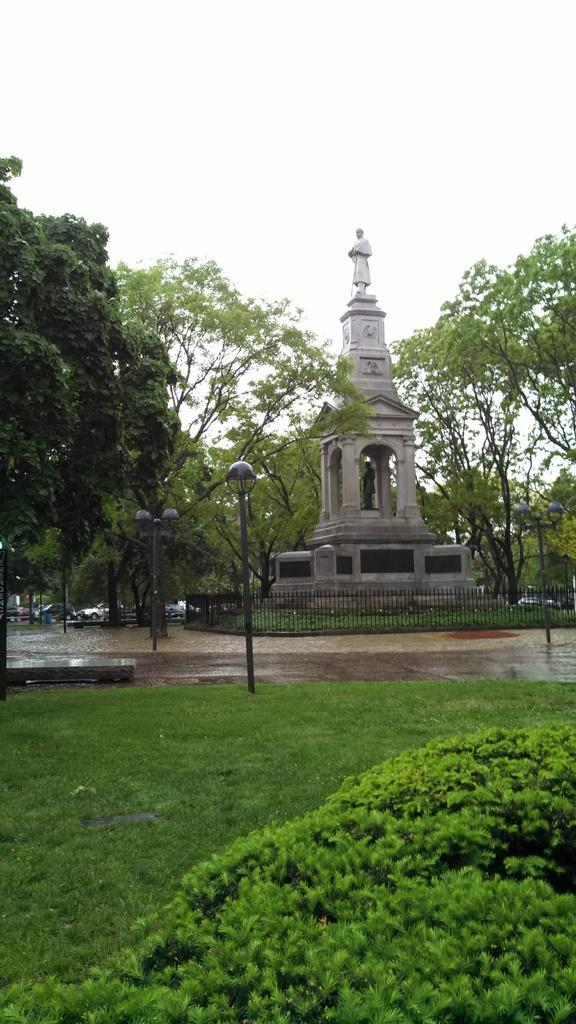In one or two sentences, can you explain what this image depicts? In the center of the image there is a statue. On the left side of the image there are trees, light poles and cars. On the right side of the image there are trees. At the bottom we can see grass and plants. In the background there is a sky. 